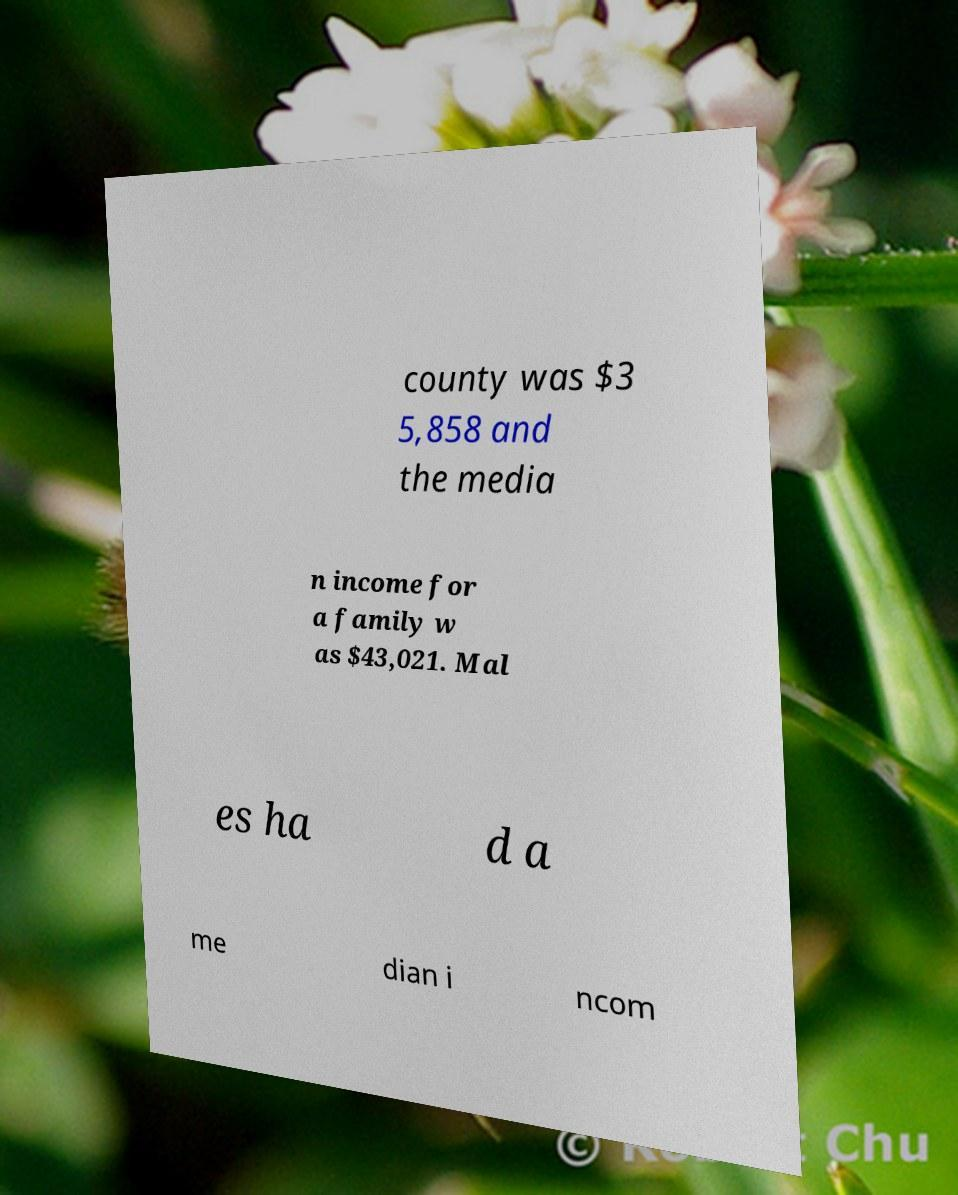Can you accurately transcribe the text from the provided image for me? county was $3 5,858 and the media n income for a family w as $43,021. Mal es ha d a me dian i ncom 